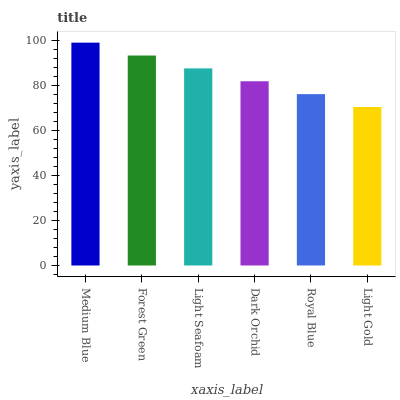Is Forest Green the minimum?
Answer yes or no. No. Is Forest Green the maximum?
Answer yes or no. No. Is Medium Blue greater than Forest Green?
Answer yes or no. Yes. Is Forest Green less than Medium Blue?
Answer yes or no. Yes. Is Forest Green greater than Medium Blue?
Answer yes or no. No. Is Medium Blue less than Forest Green?
Answer yes or no. No. Is Light Seafoam the high median?
Answer yes or no. Yes. Is Dark Orchid the low median?
Answer yes or no. Yes. Is Royal Blue the high median?
Answer yes or no. No. Is Medium Blue the low median?
Answer yes or no. No. 